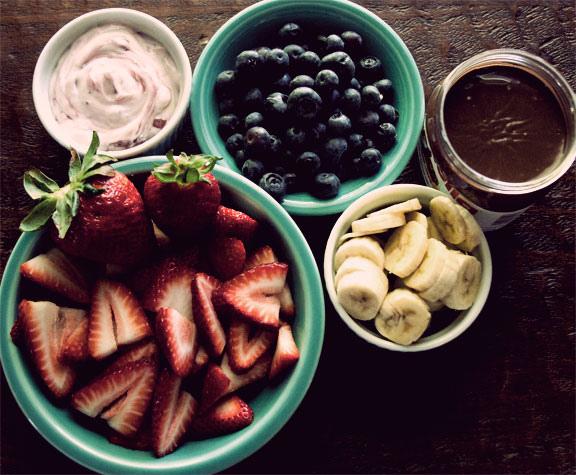Are those bananas on the bowl?
Give a very brief answer. Yes. What color bowl are the blueberries in?
Write a very short answer. Green. Are there any vegetables in the image?
Answer briefly. No. 